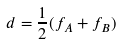<formula> <loc_0><loc_0><loc_500><loc_500>d = \frac { 1 } { 2 } ( f _ { A } + f _ { B } )</formula> 